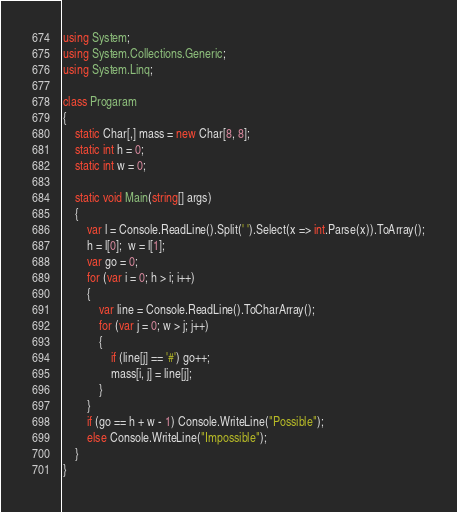Convert code to text. <code><loc_0><loc_0><loc_500><loc_500><_C#_>using System;
using System.Collections.Generic;
using System.Linq;

class Progaram
{
    static Char[,] mass = new Char[8, 8];
    static int h = 0; 
    static int w = 0;

    static void Main(string[] args)
    {
        var l = Console.ReadLine().Split(' ').Select(x => int.Parse(x)).ToArray();
        h = l[0];  w = l[1];
        var go = 0;
        for (var i = 0; h > i; i++)
        {
            var line = Console.ReadLine().ToCharArray();
            for (var j = 0; w > j; j++)
            {
                if (line[j] == '#') go++;
                mass[i, j] = line[j];
            }
        }
        if (go == h + w - 1) Console.WriteLine("Possible");
        else Console.WriteLine("Impossible");
    }
}</code> 